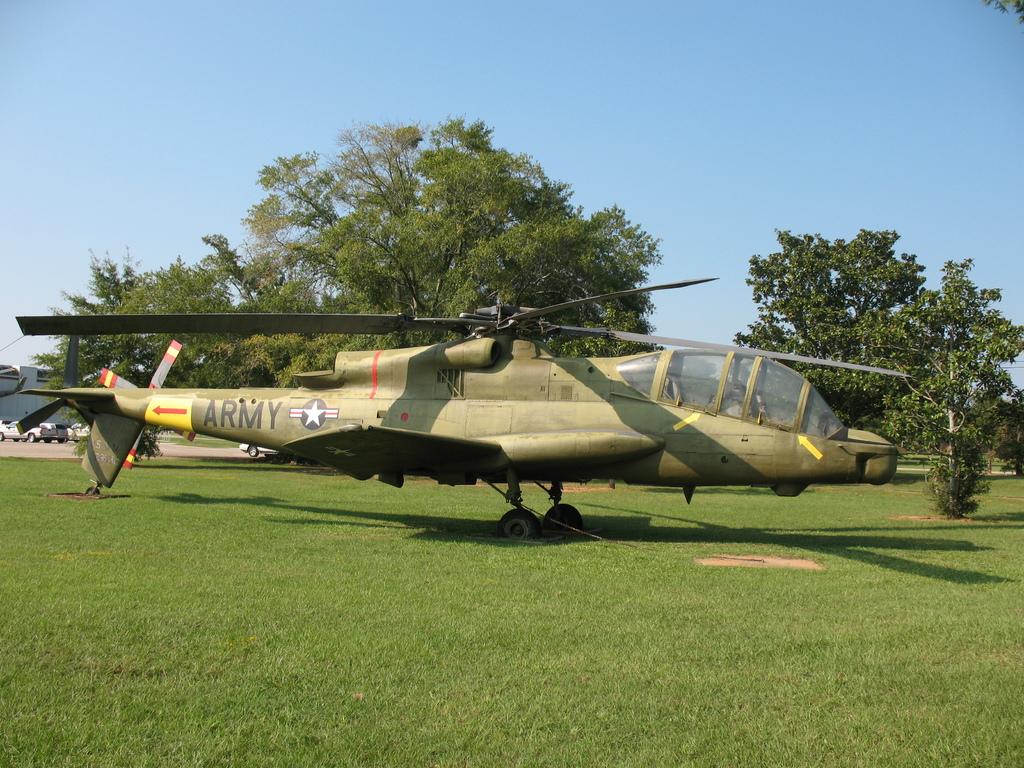What branch of the military is on the side of the helicopter?
Ensure brevity in your answer.  Army. 